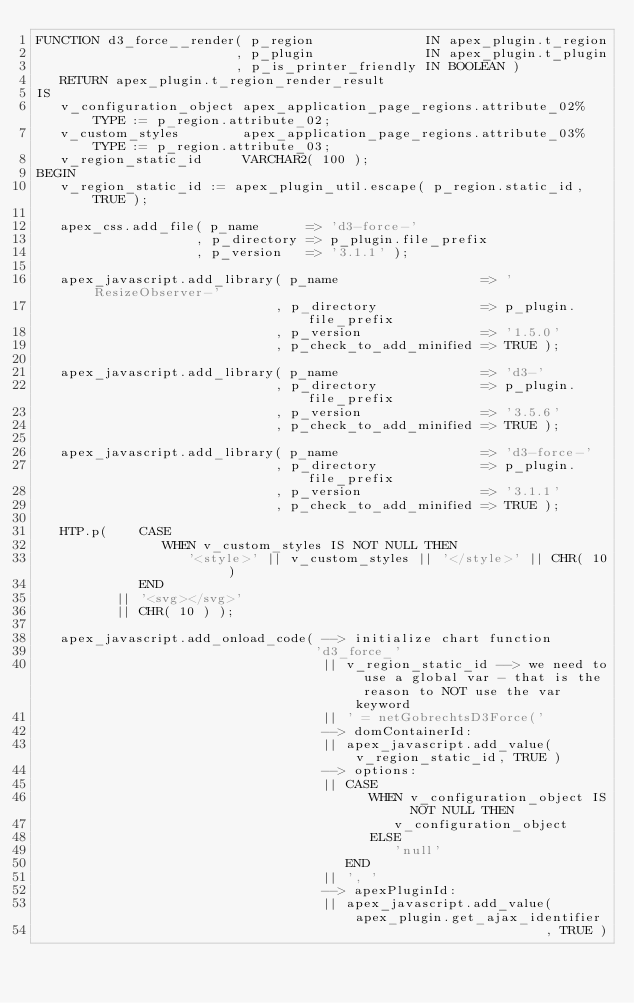<code> <loc_0><loc_0><loc_500><loc_500><_SQL_>FUNCTION d3_force__render( p_region              IN apex_plugin.t_region
                         , p_plugin              IN apex_plugin.t_plugin
                         , p_is_printer_friendly IN BOOLEAN )
   RETURN apex_plugin.t_region_render_result
IS
   v_configuration_object apex_application_page_regions.attribute_02%TYPE := p_region.attribute_02;
   v_custom_styles        apex_application_page_regions.attribute_03%TYPE := p_region.attribute_03;
   v_region_static_id     VARCHAR2( 100 );
BEGIN
   v_region_static_id := apex_plugin_util.escape( p_region.static_id, TRUE );

   apex_css.add_file( p_name      => 'd3-force-'
                    , p_directory => p_plugin.file_prefix
                    , p_version   => '3.1.1' );

   apex_javascript.add_library( p_name                  => 'ResizeObserver-'
                              , p_directory             => p_plugin.file_prefix
                              , p_version               => '1.5.0'
                              , p_check_to_add_minified => TRUE );

   apex_javascript.add_library( p_name                  => 'd3-'
                              , p_directory             => p_plugin.file_prefix
                              , p_version               => '3.5.6'
                              , p_check_to_add_minified => TRUE );

   apex_javascript.add_library( p_name                  => 'd3-force-'
                              , p_directory             => p_plugin.file_prefix
                              , p_version               => '3.1.1'
                              , p_check_to_add_minified => TRUE );

   HTP.p(    CASE
                WHEN v_custom_styles IS NOT NULL THEN
                   '<style>' || v_custom_styles || '</style>' || CHR( 10 )
             END
          || '<svg></svg>'
          || CHR( 10 ) );

   apex_javascript.add_onload_code( --> initialize chart function
                                   'd3_force_'
                                    || v_region_static_id --> we need to use a global var - that is the reason to NOT use the var keyword
                                    || ' = netGobrechtsD3Force('
                                    --> domContainerId:
                                    || apex_javascript.add_value( v_region_static_id, TRUE )
                                    --> options:
                                    || CASE
                                          WHEN v_configuration_object IS NOT NULL THEN
                                             v_configuration_object
                                          ELSE
                                             'null'
                                       END
                                    || ', '
                                    --> apexPluginId:
                                    || apex_javascript.add_value( apex_plugin.get_ajax_identifier
                                                                , TRUE )</code> 